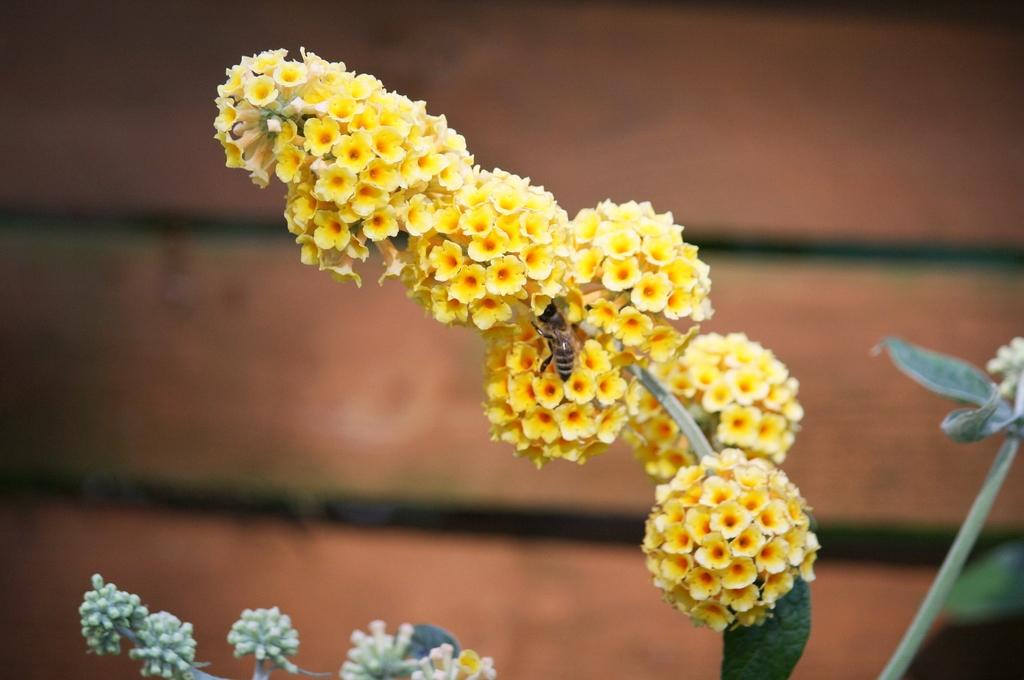What is the main subject of the image? The main subject of the image is a stem with flowers. Are there any other living creatures present in the image? Yes, there is a honey bee on the stem. What else can be seen on the stem besides flowers? There are stems and buds in the image. What can be seen in the background of the image? The background of the image is blurred, and there is a wall visible. What type of cushion is being used for the flower treatment in the image? There is no cushion or flower treatment present in the image; it features a stem with flowers and a honey bee. 